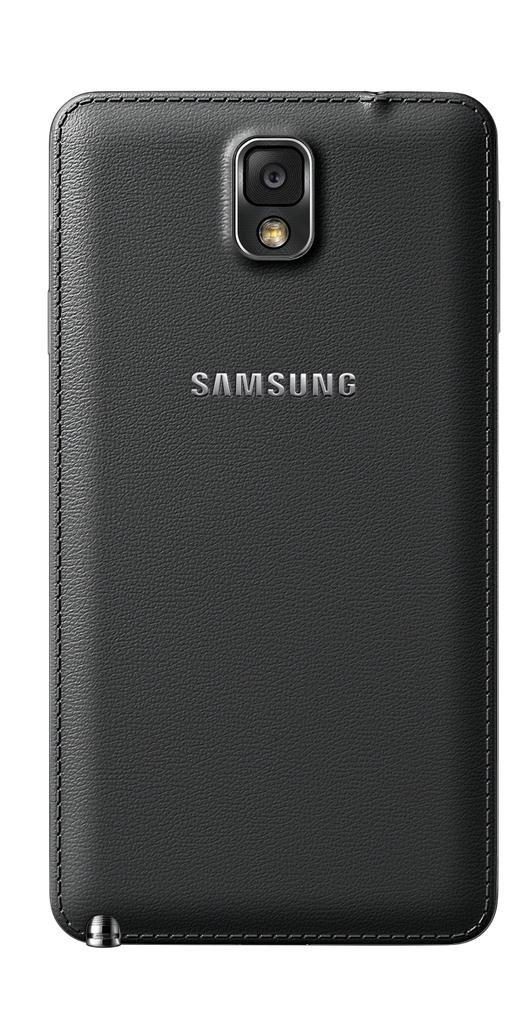<image>
Present a compact description of the photo's key features. a phone with the word samsung on it 